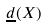Convert formula to latex. <formula><loc_0><loc_0><loc_500><loc_500>\underline { d } ( X )</formula> 